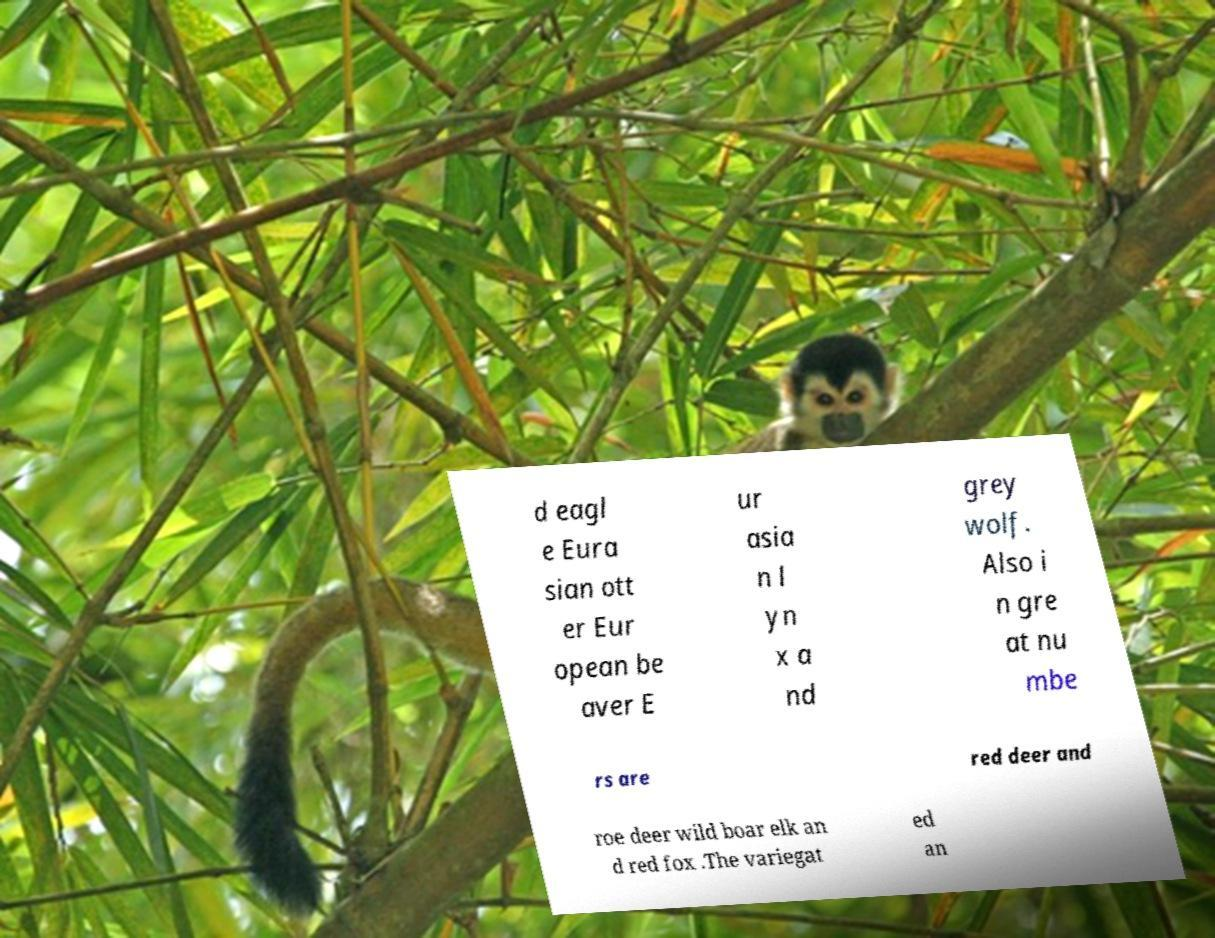What messages or text are displayed in this image? I need them in a readable, typed format. d eagl e Eura sian ott er Eur opean be aver E ur asia n l yn x a nd grey wolf. Also i n gre at nu mbe rs are red deer and roe deer wild boar elk an d red fox .The variegat ed an 